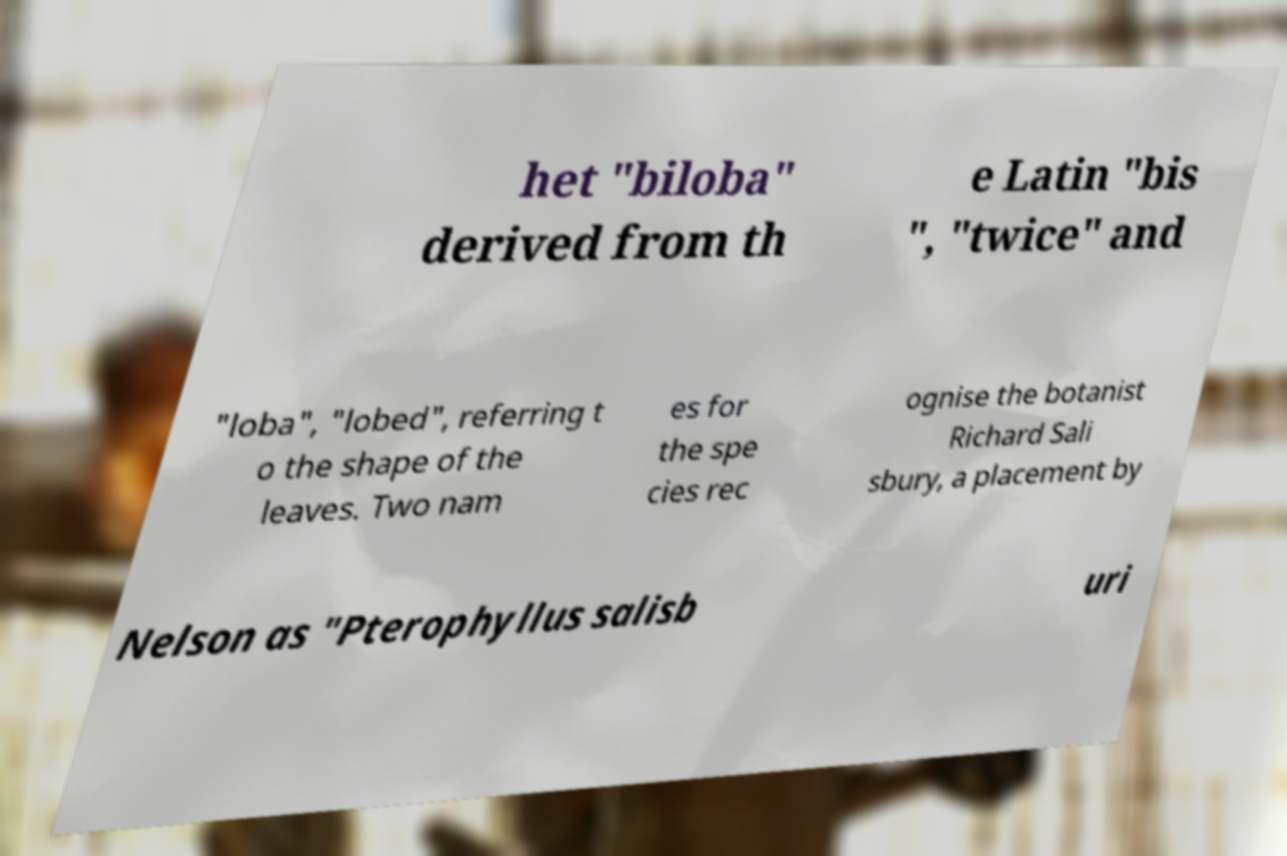Could you extract and type out the text from this image? het "biloba" derived from th e Latin "bis ", "twice" and "loba", "lobed", referring t o the shape of the leaves. Two nam es for the spe cies rec ognise the botanist Richard Sali sbury, a placement by Nelson as "Pterophyllus salisb uri 